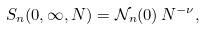Convert formula to latex. <formula><loc_0><loc_0><loc_500><loc_500>S _ { n } ( 0 , \infty , N ) = { \mathcal { N } } _ { n } ( 0 ) \, N ^ { - \nu } ,</formula> 